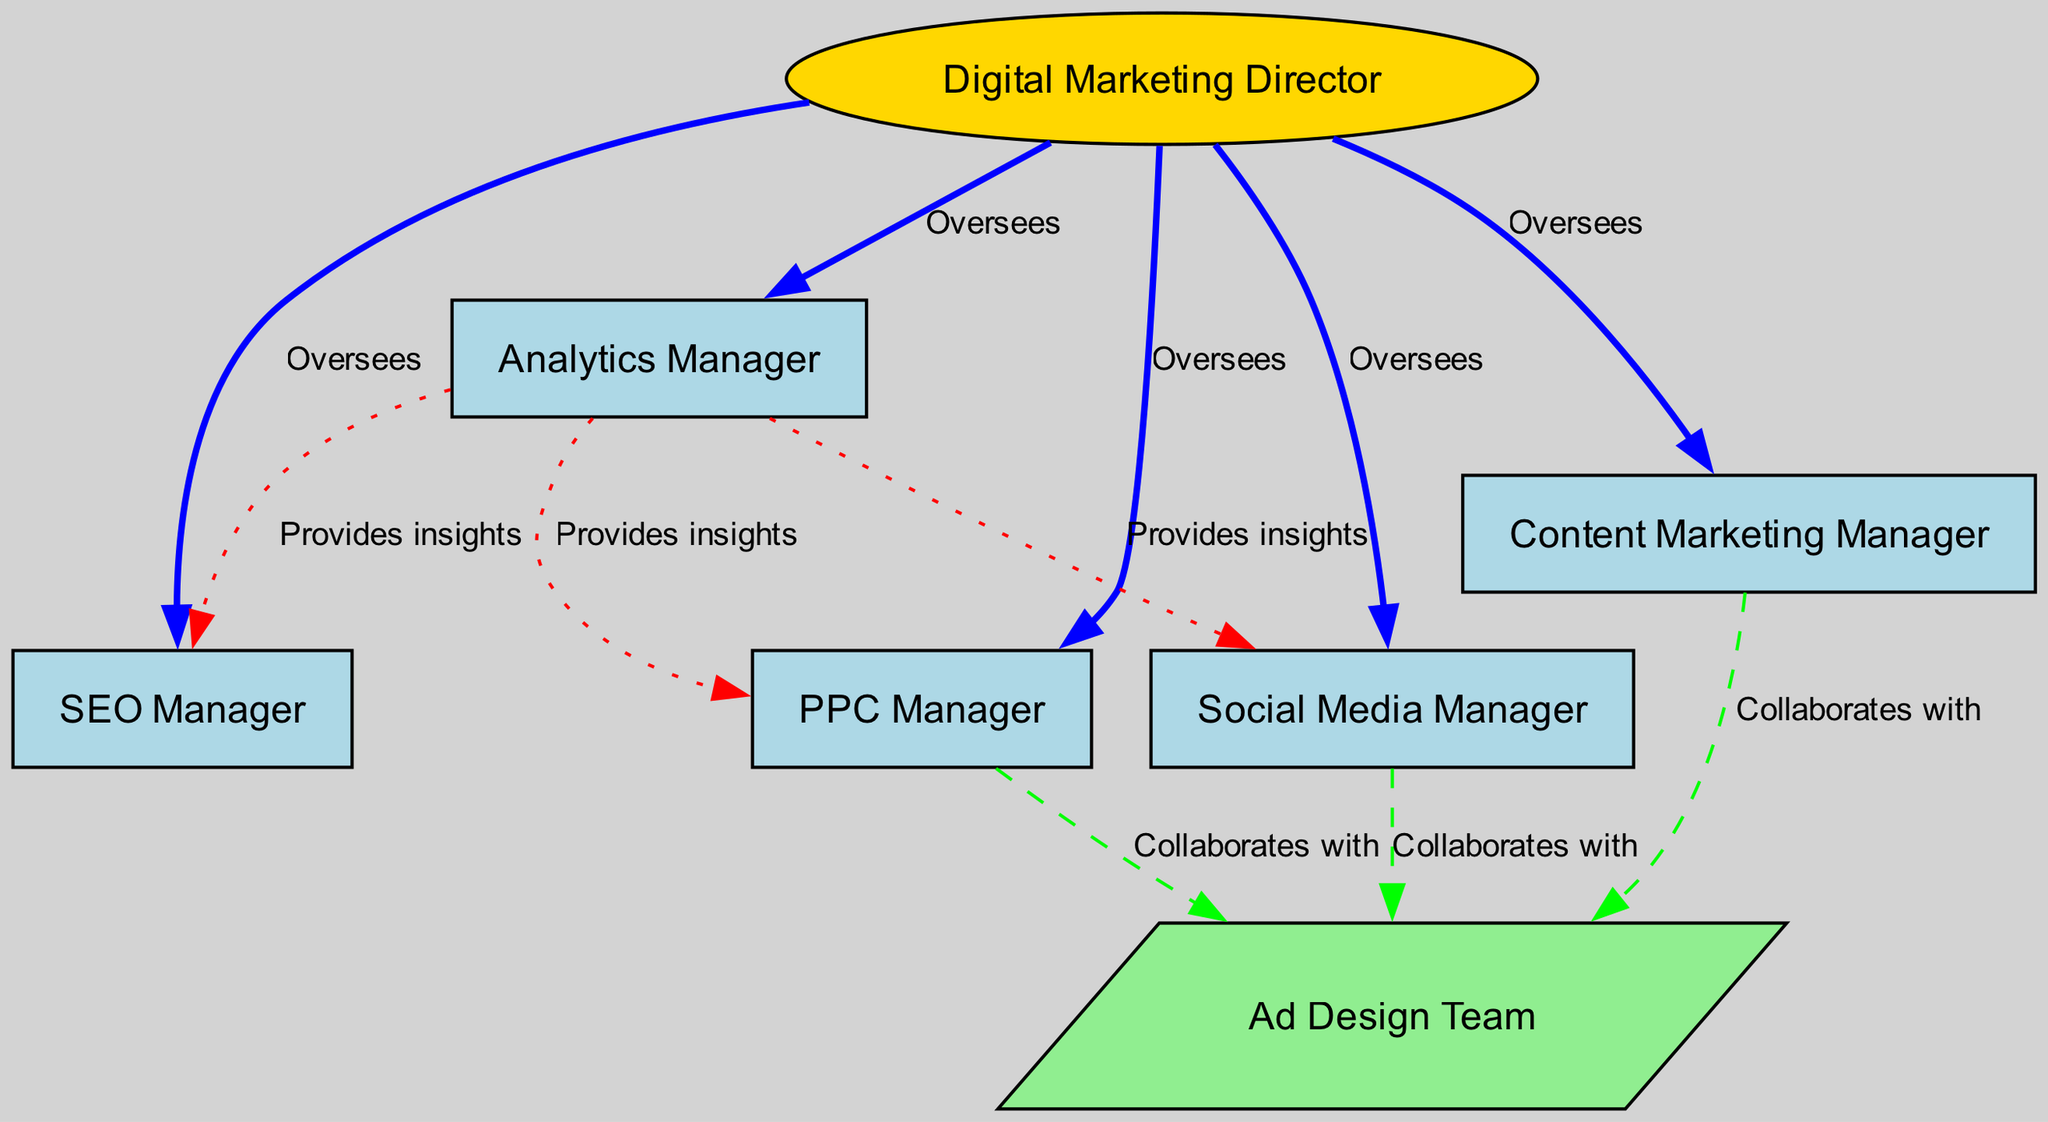What is the main role in the digital marketing team? The main role, which oversees all other roles in the team, is represented at the top of the diagram as the "Digital Marketing Director." This is determined by identifying the node with the highest hierarchy in the structure.
Answer: Digital Marketing Director How many roles report to the Digital Marketing Director? To find the number of roles reporting to the Digital Marketing Director, we look at the outgoing edges from that node. There are five edges connecting to other roles (SEO Manager, PPC Manager, Social Media Manager, Content Marketing Manager, and Analytics Manager).
Answer: Five What type of node is the Ad Design Team? The Ad Design Team is represented as a parallelogram shape in the diagram, which indicates its special role in the structure. We can observe this by examining the shapes assigned to each node.
Answer: Parallelogram Which role collaborates with the Ad Design Team, but does not report to the Digital Marketing Director? The roles that collaborate with the Ad Design Team are the PPC Manager, Social Media Manager, and Content Marketing Manager. Out of these, only Content Marketing Manager does not have a direct oversight relationship with the Digital Marketing Director, as it has only a collaboration line going to the Ad Design Team instead of an overseeing relationship.
Answer: Content Marketing Manager Which roles receive insights from the Analytics Manager? The roles receiving insights from the Analytics Manager are the SEO Manager, PPC Manager, and Social Media Manager. To determine this, we trace the edges labeled "Provides insights" that originate from the Analytics Manager.
Answer: SEO Manager, PPC Manager, Social Media Manager What color represents the relationship between roles that are overseen by the Digital Marketing Director? The relationships between the Digital Marketing Director and the other roles that he/she oversees are shown in blue color representing 'Oversees.' This can be identified by observing the edges from the Digital Marketing Director node.
Answer: Blue How many total roles are included in the diagram? The total number of roles in the diagram can be calculated by counting all the nodes presented. There are seven nodes in total corresponding to the various roles within the digital marketing team as shown in the diagram.
Answer: Seven Which role provides directly to the SEO Manager? The Analytics Manager directly provides insights to the SEO Manager, as indicated by the edge labeled "Provides insights" from the Analytics Manager to the SEO Manager in the diagram.
Answer: Analytics Manager What is the relationship type between the PPC Manager and Ad Design Team? The relationship between the PPC Manager and Ad Design Team is labeled as "Collaborates with," which indicates a partnership or cooperation rather than a reporting line. This can be seen by checking the edges connected to each of these roles.
Answer: Collaborates with 